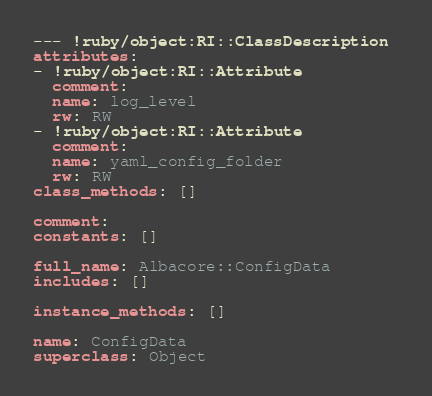Convert code to text. <code><loc_0><loc_0><loc_500><loc_500><_YAML_>--- !ruby/object:RI::ClassDescription 
attributes: 
- !ruby/object:RI::Attribute 
  comment: 
  name: log_level
  rw: RW
- !ruby/object:RI::Attribute 
  comment: 
  name: yaml_config_folder
  rw: RW
class_methods: []

comment: 
constants: []

full_name: Albacore::ConfigData
includes: []

instance_methods: []

name: ConfigData
superclass: Object
</code> 